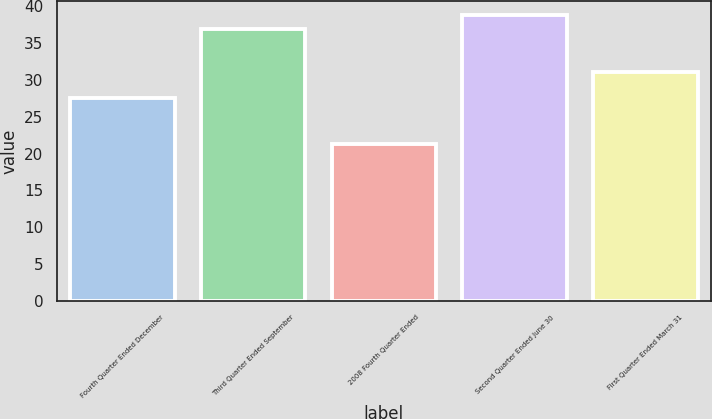Convert chart to OTSL. <chart><loc_0><loc_0><loc_500><loc_500><bar_chart><fcel>Fourth Quarter Ended December<fcel>Third Quarter Ended September<fcel>2008 Fourth Quarter Ended<fcel>Second Quarter Ended June 30<fcel>First Quarter Ended March 31<nl><fcel>27.54<fcel>36.84<fcel>21.27<fcel>38.74<fcel>31.07<nl></chart> 